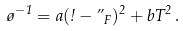Convert formula to latex. <formula><loc_0><loc_0><loc_500><loc_500>\tau ^ { - 1 } = a ( \omega - \varepsilon _ { F } ) ^ { 2 } + b T ^ { 2 } \, .</formula> 